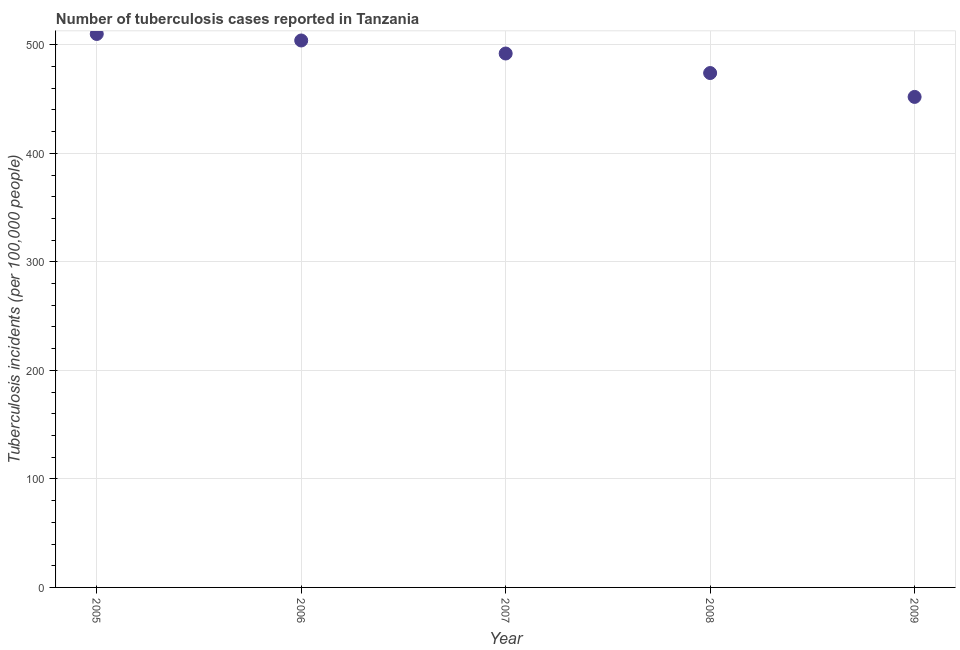What is the number of tuberculosis incidents in 2009?
Keep it short and to the point. 452. Across all years, what is the maximum number of tuberculosis incidents?
Ensure brevity in your answer.  510. Across all years, what is the minimum number of tuberculosis incidents?
Offer a terse response. 452. In which year was the number of tuberculosis incidents maximum?
Offer a very short reply. 2005. What is the sum of the number of tuberculosis incidents?
Ensure brevity in your answer.  2432. What is the difference between the number of tuberculosis incidents in 2005 and 2007?
Offer a terse response. 18. What is the average number of tuberculosis incidents per year?
Provide a succinct answer. 486.4. What is the median number of tuberculosis incidents?
Make the answer very short. 492. In how many years, is the number of tuberculosis incidents greater than 40 ?
Provide a succinct answer. 5. What is the ratio of the number of tuberculosis incidents in 2006 to that in 2009?
Give a very brief answer. 1.12. What is the difference between the highest and the second highest number of tuberculosis incidents?
Your answer should be compact. 6. Is the sum of the number of tuberculosis incidents in 2008 and 2009 greater than the maximum number of tuberculosis incidents across all years?
Offer a very short reply. Yes. What is the difference between the highest and the lowest number of tuberculosis incidents?
Make the answer very short. 58. In how many years, is the number of tuberculosis incidents greater than the average number of tuberculosis incidents taken over all years?
Provide a succinct answer. 3. What is the difference between two consecutive major ticks on the Y-axis?
Give a very brief answer. 100. Are the values on the major ticks of Y-axis written in scientific E-notation?
Keep it short and to the point. No. Does the graph contain any zero values?
Your answer should be compact. No. What is the title of the graph?
Give a very brief answer. Number of tuberculosis cases reported in Tanzania. What is the label or title of the Y-axis?
Your answer should be compact. Tuberculosis incidents (per 100,0 people). What is the Tuberculosis incidents (per 100,000 people) in 2005?
Your answer should be compact. 510. What is the Tuberculosis incidents (per 100,000 people) in 2006?
Give a very brief answer. 504. What is the Tuberculosis incidents (per 100,000 people) in 2007?
Ensure brevity in your answer.  492. What is the Tuberculosis incidents (per 100,000 people) in 2008?
Ensure brevity in your answer.  474. What is the Tuberculosis incidents (per 100,000 people) in 2009?
Your response must be concise. 452. What is the difference between the Tuberculosis incidents (per 100,000 people) in 2005 and 2008?
Ensure brevity in your answer.  36. What is the difference between the Tuberculosis incidents (per 100,000 people) in 2006 and 2008?
Give a very brief answer. 30. What is the difference between the Tuberculosis incidents (per 100,000 people) in 2006 and 2009?
Offer a very short reply. 52. What is the difference between the Tuberculosis incidents (per 100,000 people) in 2007 and 2009?
Provide a succinct answer. 40. What is the ratio of the Tuberculosis incidents (per 100,000 people) in 2005 to that in 2006?
Ensure brevity in your answer.  1.01. What is the ratio of the Tuberculosis incidents (per 100,000 people) in 2005 to that in 2008?
Give a very brief answer. 1.08. What is the ratio of the Tuberculosis incidents (per 100,000 people) in 2005 to that in 2009?
Your response must be concise. 1.13. What is the ratio of the Tuberculosis incidents (per 100,000 people) in 2006 to that in 2008?
Offer a terse response. 1.06. What is the ratio of the Tuberculosis incidents (per 100,000 people) in 2006 to that in 2009?
Make the answer very short. 1.11. What is the ratio of the Tuberculosis incidents (per 100,000 people) in 2007 to that in 2008?
Your answer should be very brief. 1.04. What is the ratio of the Tuberculosis incidents (per 100,000 people) in 2007 to that in 2009?
Make the answer very short. 1.09. What is the ratio of the Tuberculosis incidents (per 100,000 people) in 2008 to that in 2009?
Give a very brief answer. 1.05. 